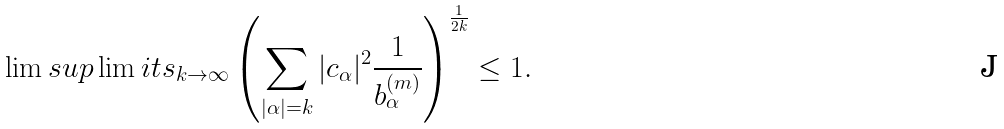<formula> <loc_0><loc_0><loc_500><loc_500>\lim s u p \lim i t s _ { k \to \infty } \left ( \sum _ { | \alpha | = k } | c _ { \alpha } | ^ { 2 } \frac { 1 } { b _ { \alpha } ^ { ( m ) } } \right ) ^ { \frac { 1 } { 2 k } } \leq 1 .</formula> 